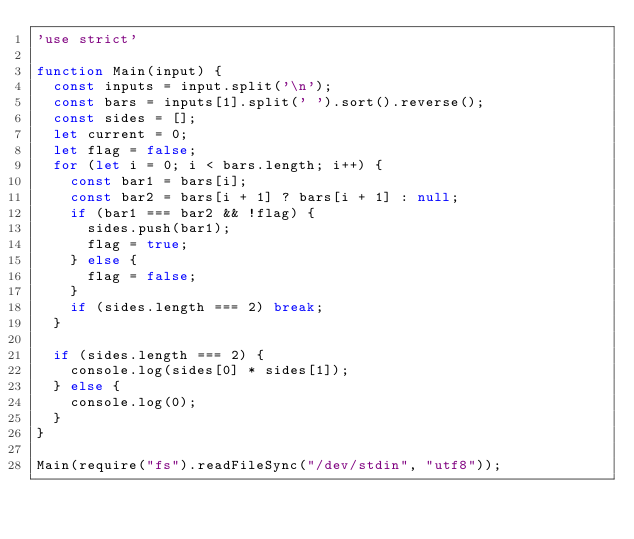Convert code to text. <code><loc_0><loc_0><loc_500><loc_500><_JavaScript_>'use strict'

function Main(input) {
  const inputs = input.split('\n');
  const bars = inputs[1].split(' ').sort().reverse();
  const sides = [];
  let current = 0;
  let flag = false;
  for (let i = 0; i < bars.length; i++) {
	const bar1 = bars[i];
    const bar2 = bars[i + 1] ? bars[i + 1] : null;
    if (bar1 === bar2 && !flag) {
      sides.push(bar1);
      flag = true;
    } else {
      flag = false;
    }
    if (sides.length === 2) break;
  }

  if (sides.length === 2) {
    console.log(sides[0] * sides[1]);
  } else {
    console.log(0);
  }
}

Main(require("fs").readFileSync("/dev/stdin", "utf8"));
</code> 